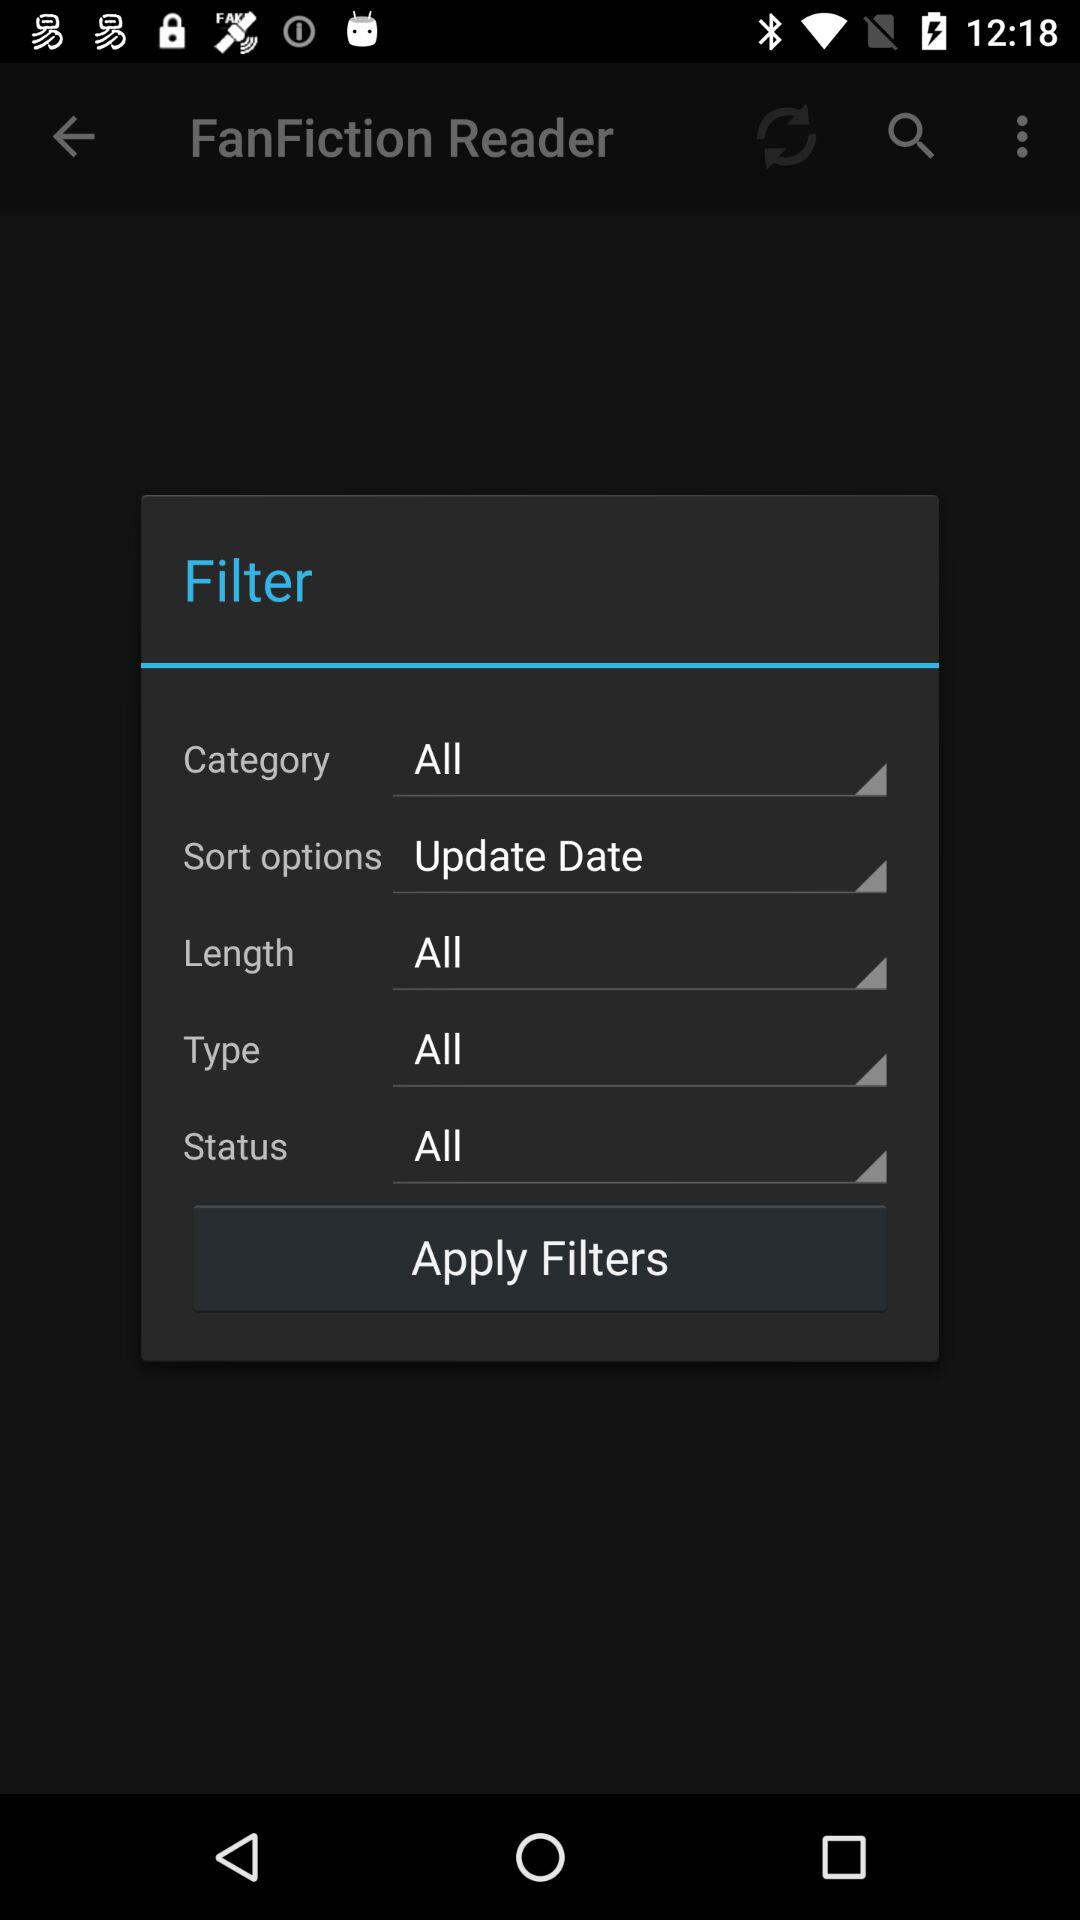What is the selected category? The selected category is "All". 